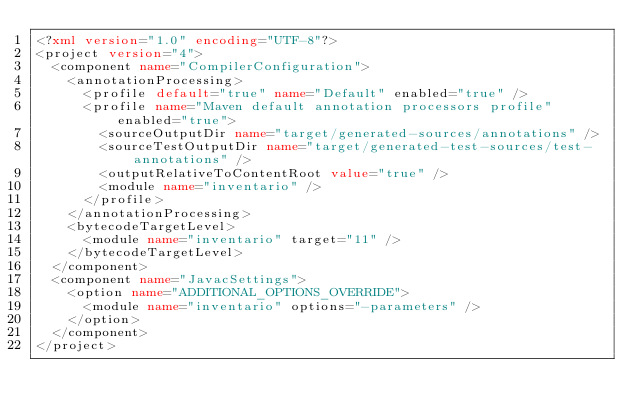<code> <loc_0><loc_0><loc_500><loc_500><_XML_><?xml version="1.0" encoding="UTF-8"?>
<project version="4">
  <component name="CompilerConfiguration">
    <annotationProcessing>
      <profile default="true" name="Default" enabled="true" />
      <profile name="Maven default annotation processors profile" enabled="true">
        <sourceOutputDir name="target/generated-sources/annotations" />
        <sourceTestOutputDir name="target/generated-test-sources/test-annotations" />
        <outputRelativeToContentRoot value="true" />
        <module name="inventario" />
      </profile>
    </annotationProcessing>
    <bytecodeTargetLevel>
      <module name="inventario" target="11" />
    </bytecodeTargetLevel>
  </component>
  <component name="JavacSettings">
    <option name="ADDITIONAL_OPTIONS_OVERRIDE">
      <module name="inventario" options="-parameters" />
    </option>
  </component>
</project></code> 